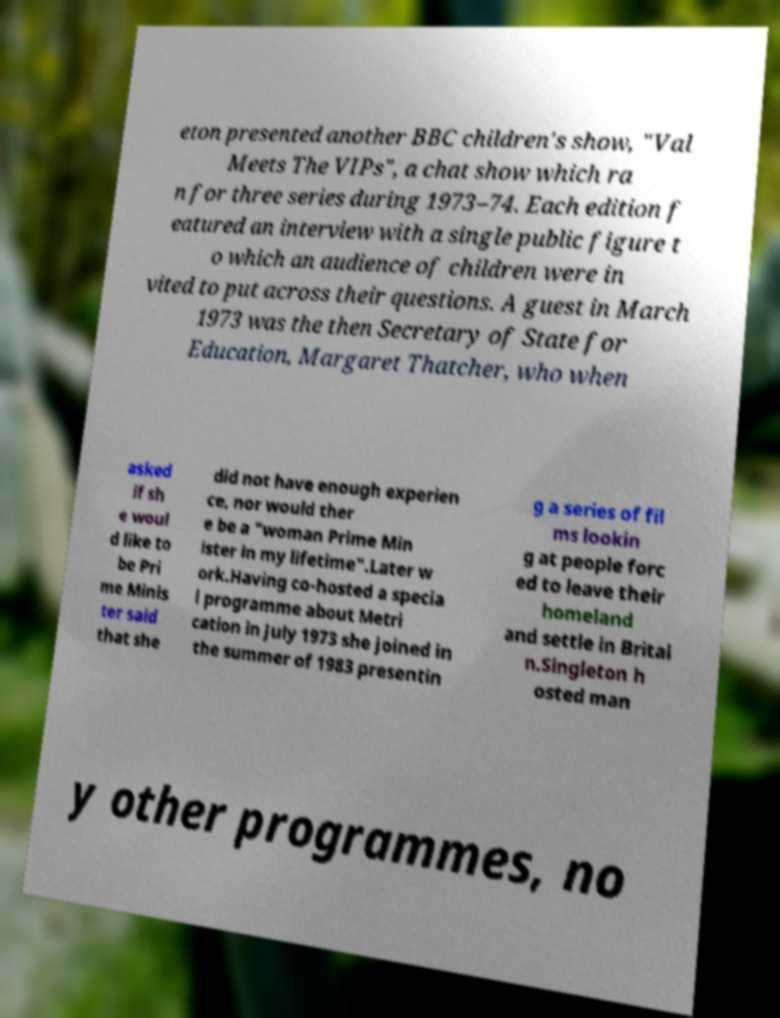I need the written content from this picture converted into text. Can you do that? eton presented another BBC children's show, "Val Meets The VIPs", a chat show which ra n for three series during 1973–74. Each edition f eatured an interview with a single public figure t o which an audience of children were in vited to put across their questions. A guest in March 1973 was the then Secretary of State for Education, Margaret Thatcher, who when asked if sh e woul d like to be Pri me Minis ter said that she did not have enough experien ce, nor would ther e be a "woman Prime Min ister in my lifetime".Later w ork.Having co-hosted a specia l programme about Metri cation in July 1973 she joined in the summer of 1983 presentin g a series of fil ms lookin g at people forc ed to leave their homeland and settle in Britai n.Singleton h osted man y other programmes, no 